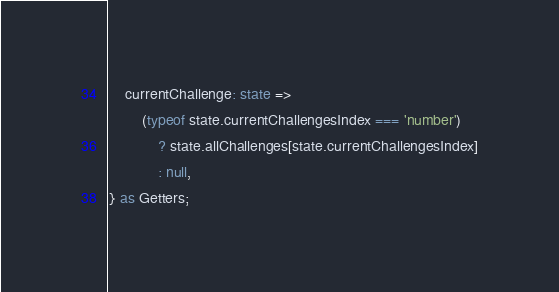Convert code to text. <code><loc_0><loc_0><loc_500><loc_500><_TypeScript_>	currentChallenge: state =>
		(typeof state.currentChallengesIndex === 'number')
			? state.allChallenges[state.currentChallengesIndex]
			: null,
} as Getters;
</code> 